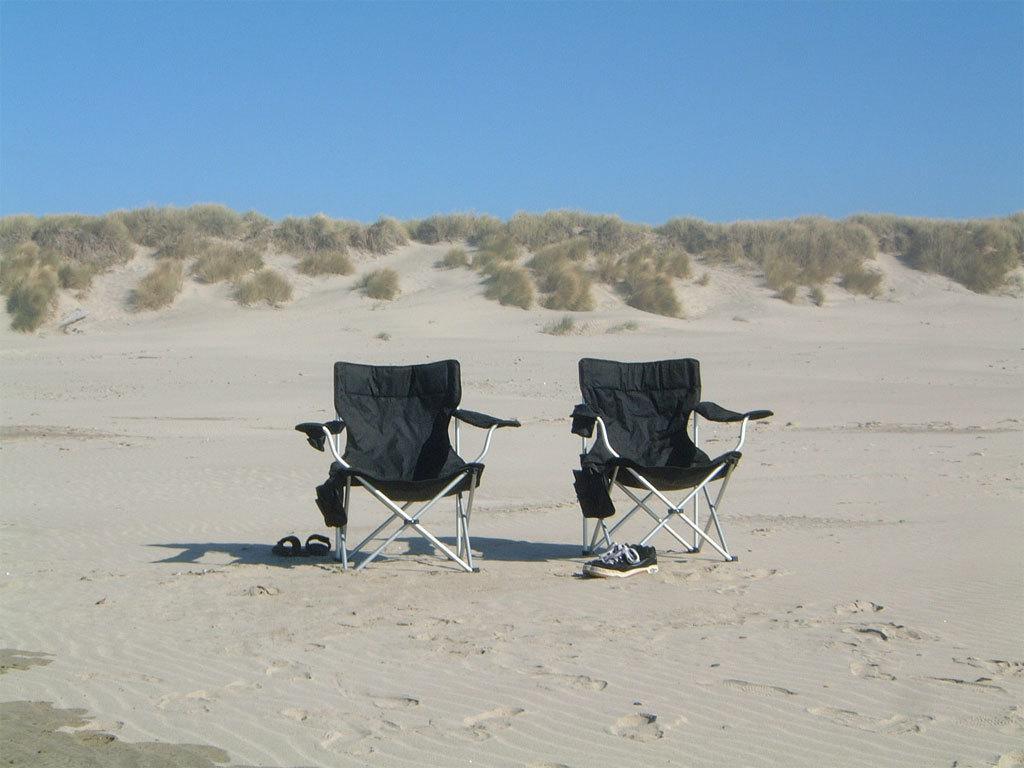How would you summarize this image in a sentence or two? In this picture I can see two chairs and foot wears on the ground. In the background I can see planets and sky. 